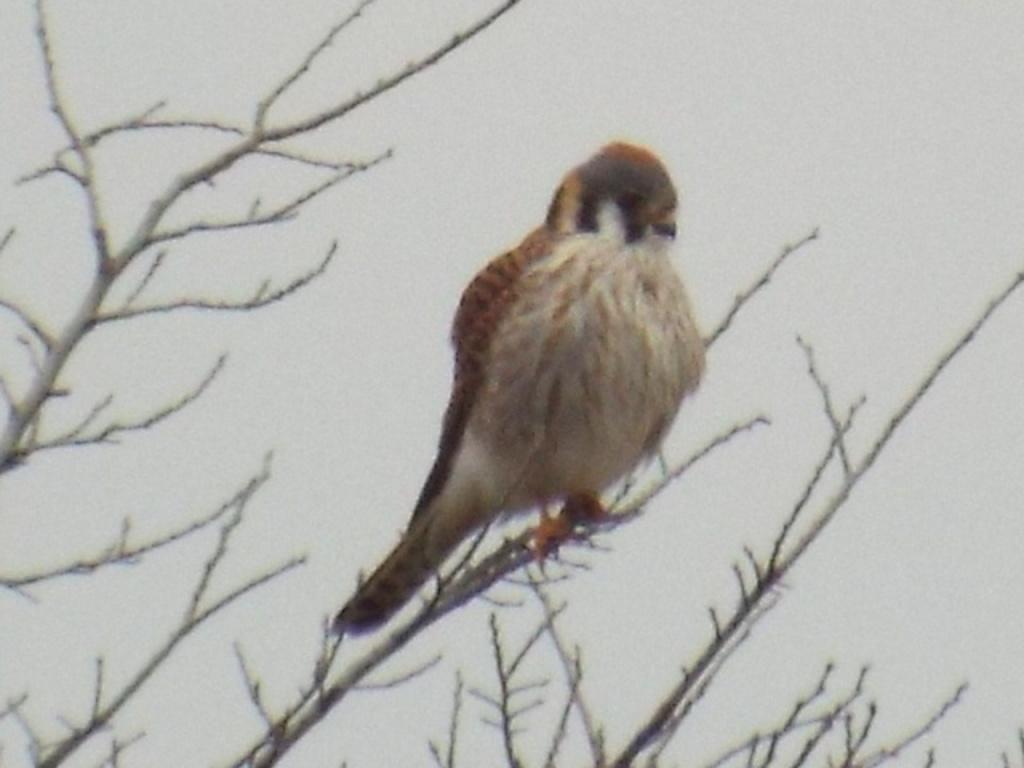Please provide a concise description of this image. In this image we can see a bird on the tree and in the background, we can see the sky. 